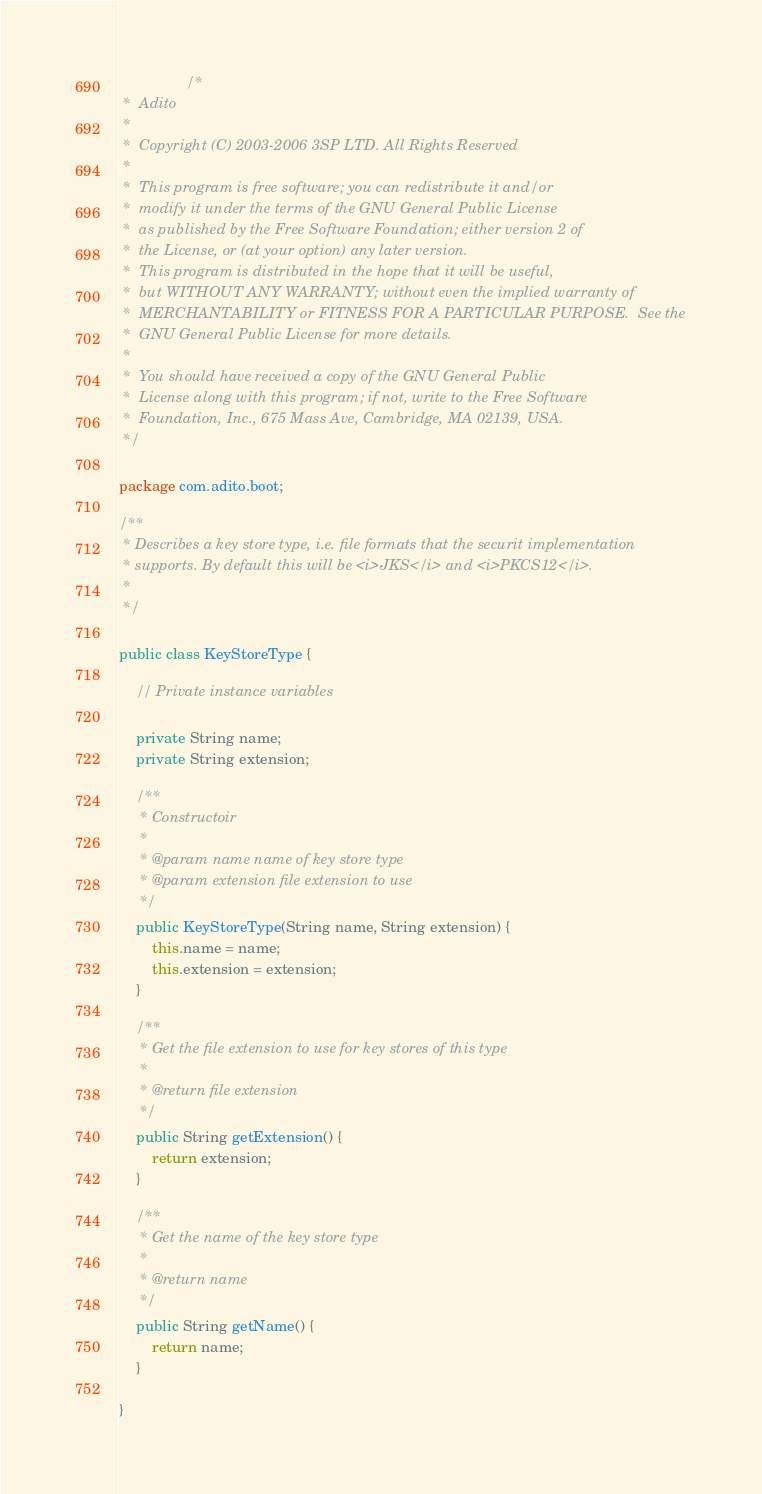<code> <loc_0><loc_0><loc_500><loc_500><_Java_>
				/*
 *  Adito
 *
 *  Copyright (C) 2003-2006 3SP LTD. All Rights Reserved
 *
 *  This program is free software; you can redistribute it and/or
 *  modify it under the terms of the GNU General Public License
 *  as published by the Free Software Foundation; either version 2 of
 *  the License, or (at your option) any later version.
 *  This program is distributed in the hope that it will be useful,
 *  but WITHOUT ANY WARRANTY; without even the implied warranty of
 *  MERCHANTABILITY or FITNESS FOR A PARTICULAR PURPOSE.  See the
 *  GNU General Public License for more details.
 *
 *  You should have received a copy of the GNU General Public
 *  License along with this program; if not, write to the Free Software
 *  Foundation, Inc., 675 Mass Ave, Cambridge, MA 02139, USA.
 */
			
package com.adito.boot;

/**
 * Describes a key store type, i.e. file formats that the securit implementation
 * supports. By default this will be <i>JKS</i> and <i>PKCS12</i>. 
 * 
 */

public class KeyStoreType {
    
    // Private instance variables
    
    private String name;
    private String extension;

    /**
     * Constructoir
     * 
     * @param name name of key store type
     * @param extension file extension to use
     */
    public KeyStoreType(String name, String extension) {
        this.name = name;
        this.extension = extension;
    }

    /**
     * Get the file extension to use for key stores of this type
     * 
     * @return file extension
     */
    public String getExtension() {
        return extension;
    }

    /**
     * Get the name of the key store type
     * 
     * @return name
     */
    public String getName() {
        return name;
    }

}
</code> 